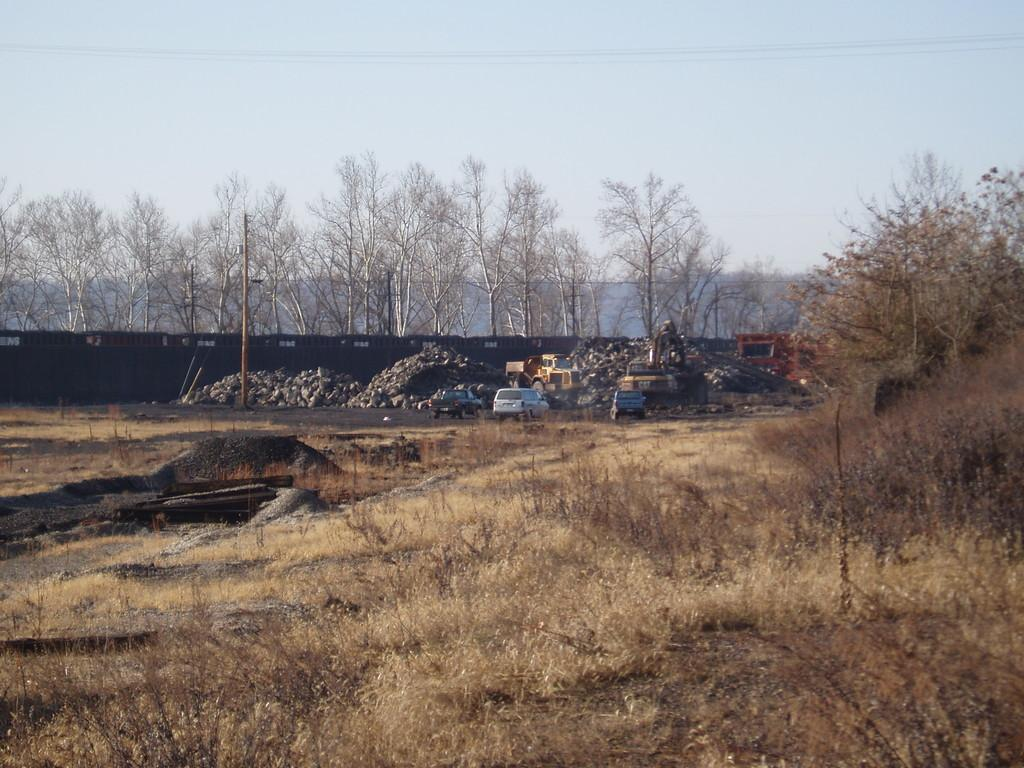What types of vehicles can be seen on the ground in the image? There are vehicles on the ground in the image, but the specific types are not mentioned. What is the tall, vertical object in the image? Yes, there is a pole in the image. What is the barrier-like structure in the image? There is a fence in the image. What type of vegetation is present in the image? There are trees in the image. What can be seen in the background of the image? The sky is visible in the background of the image. What type of juice is being served in the image? There is no juice present in the image. How many pigs are visible in the image? There are no pigs present in the image. 